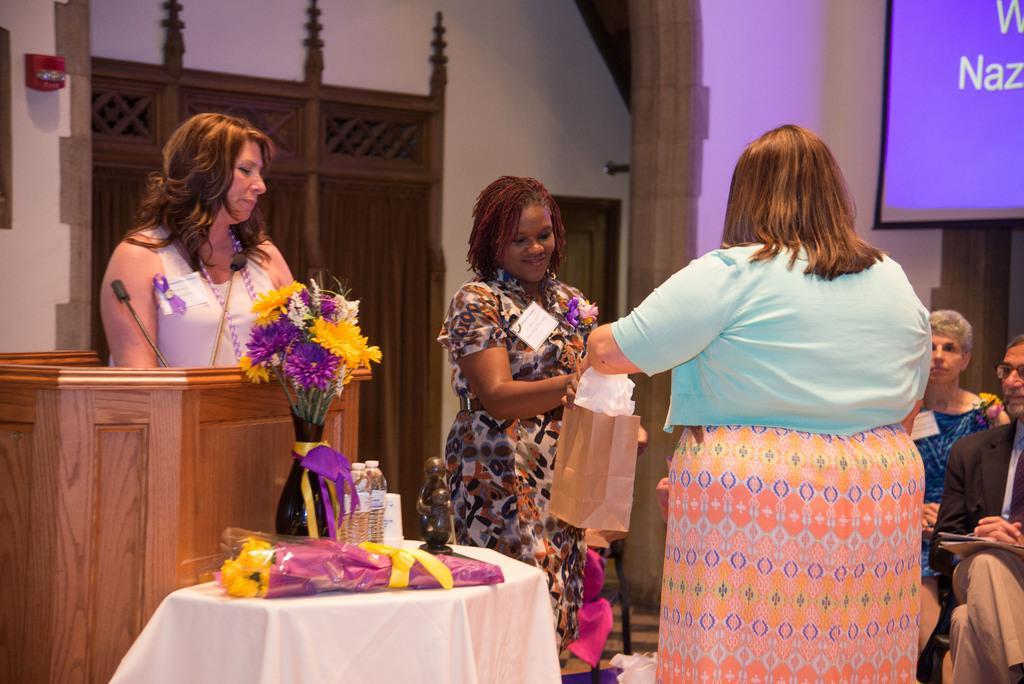Describe this image in one or two sentences. In this image I can see there are three woman visible, on the right side I can see two persons, in the middle I can see podium and flower vase and boo key kept on the table and I can see a white color cloth on the table. at the top I can see the wall and the window. 